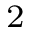Convert formula to latex. <formula><loc_0><loc_0><loc_500><loc_500>_ { 2 }</formula> 